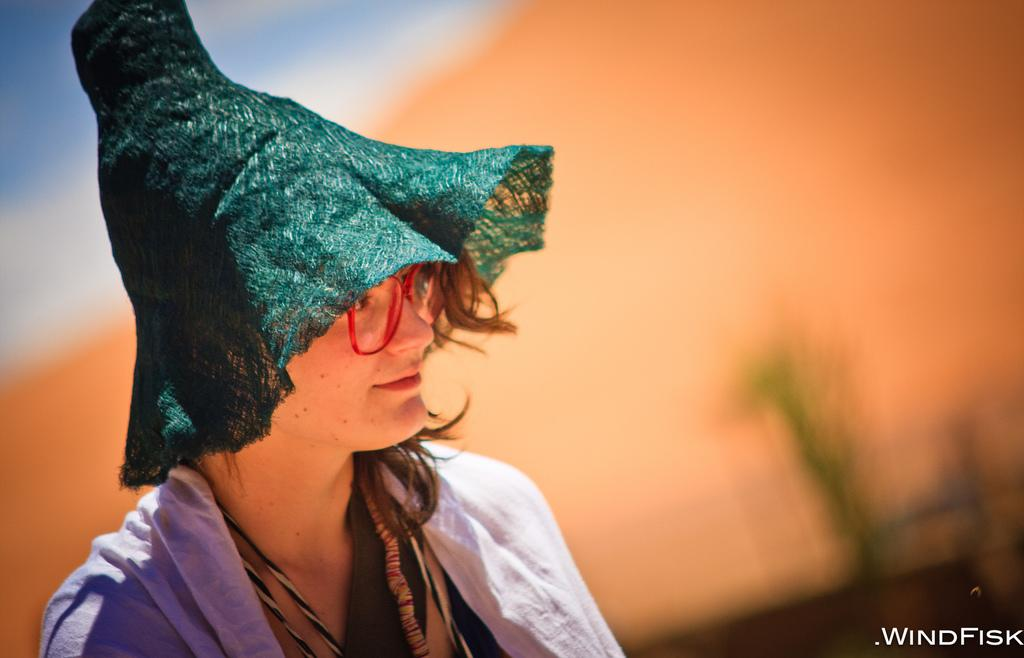Who is the main subject in the image? There is a woman in the image. What protective gear is the woman wearing? The woman is wearing goggles. What type of headwear is the woman wearing? The woman is wearing a hat. Can you describe the watermark in the image? There is a watermark in the right corner of the image. How would you describe the background of the image? The background of the image is blurred. What type of lettuce is the woman holding in the image? There is no lettuce present in the image; the woman is wearing goggles and a hat. What color is the dress the woman is wearing in the image? The woman is not wearing a dress in the image; she is wearing goggles, a hat, and possibly other clothing items that are not specified. 